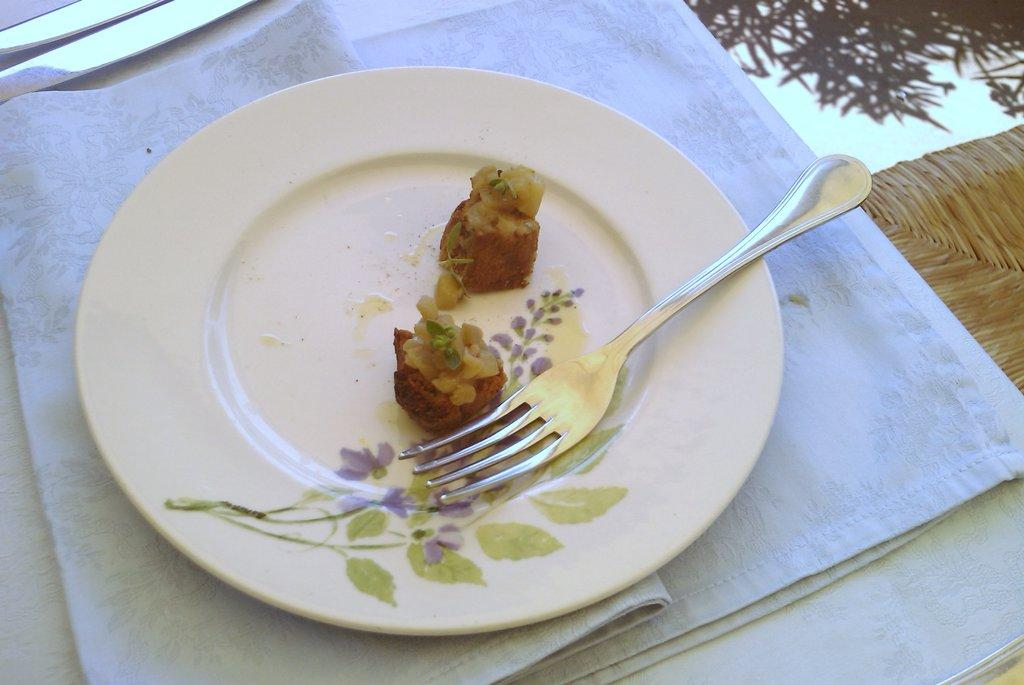What is placed on the white cloth in the image? There is a plate on the white cloth in the image. What is on the plate? There is a fork and a food item on the plate. What type of surface is the plate resting on? The scene appears to be a table. What can be seen on the right side of the image? There is a wooden object on the right side of the image. How many toes are visible in the image? There are no toes visible in the image. What type of hydrant is present in the image? There is no hydrant present in the image. 